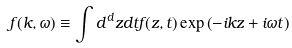Convert formula to latex. <formula><loc_0><loc_0><loc_500><loc_500>f ( { k } , \omega ) \equiv \int d ^ { d } z d t f ( { z } , t ) \exp \left ( - i { k } { z } + i \omega t \right )</formula> 